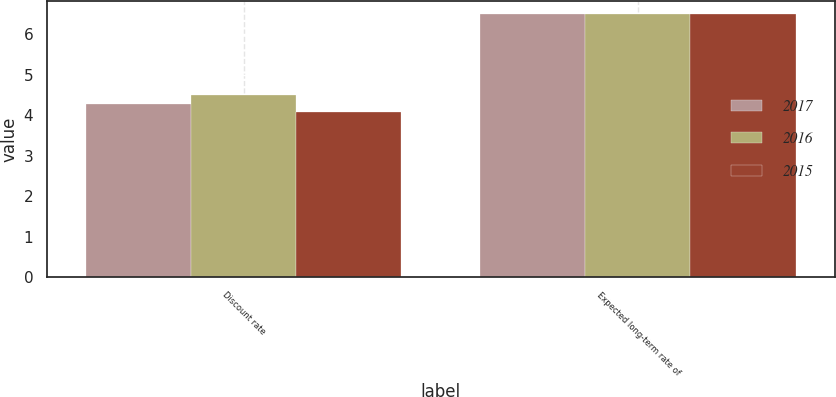Convert chart to OTSL. <chart><loc_0><loc_0><loc_500><loc_500><stacked_bar_chart><ecel><fcel>Discount rate<fcel>Expected long-term rate of<nl><fcel>2017<fcel>4.29<fcel>6.5<nl><fcel>2016<fcel>4.5<fcel>6.5<nl><fcel>2015<fcel>4.08<fcel>6.5<nl></chart> 